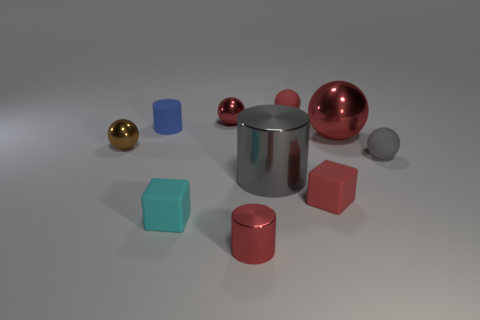Subtract all tiny cylinders. How many cylinders are left? 1 Subtract all gray spheres. How many spheres are left? 4 Subtract all cyan blocks. Subtract all yellow balls. How many blocks are left? 1 Subtract all gray blocks. How many blue cylinders are left? 1 Subtract all red metal balls. Subtract all gray cylinders. How many objects are left? 7 Add 4 small brown balls. How many small brown balls are left? 5 Add 5 small gray rubber balls. How many small gray rubber balls exist? 6 Subtract 1 cyan blocks. How many objects are left? 9 Subtract all cylinders. How many objects are left? 7 Subtract 1 blocks. How many blocks are left? 1 